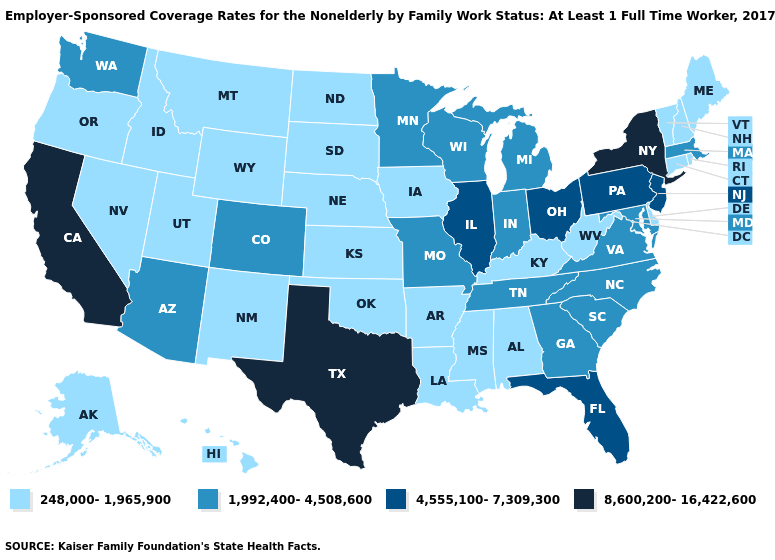Name the states that have a value in the range 4,555,100-7,309,300?
Concise answer only. Florida, Illinois, New Jersey, Ohio, Pennsylvania. Does New York have the highest value in the Northeast?
Write a very short answer. Yes. Is the legend a continuous bar?
Write a very short answer. No. Does Oklahoma have the highest value in the South?
Answer briefly. No. What is the value of North Carolina?
Concise answer only. 1,992,400-4,508,600. Does Pennsylvania have the lowest value in the Northeast?
Answer briefly. No. Name the states that have a value in the range 8,600,200-16,422,600?
Short answer required. California, New York, Texas. Does Maryland have the same value as New Hampshire?
Be succinct. No. Name the states that have a value in the range 4,555,100-7,309,300?
Be succinct. Florida, Illinois, New Jersey, Ohio, Pennsylvania. Does the first symbol in the legend represent the smallest category?
Answer briefly. Yes. What is the value of New York?
Short answer required. 8,600,200-16,422,600. Among the states that border Utah , which have the highest value?
Write a very short answer. Arizona, Colorado. What is the highest value in the Northeast ?
Keep it brief. 8,600,200-16,422,600. Among the states that border Vermont , which have the lowest value?
Write a very short answer. New Hampshire. How many symbols are there in the legend?
Concise answer only. 4. 